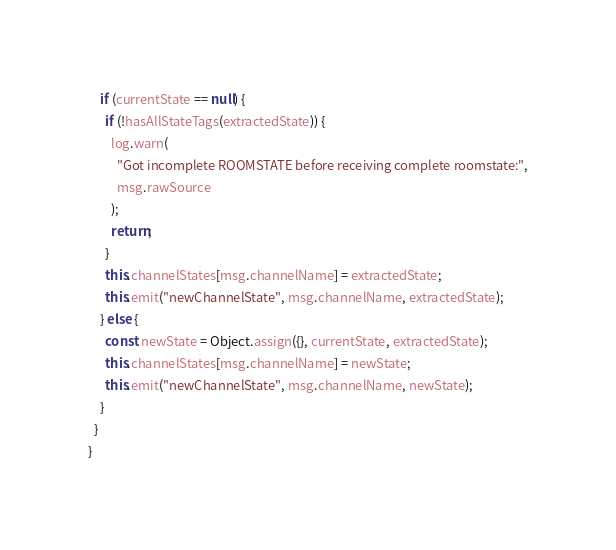Convert code to text. <code><loc_0><loc_0><loc_500><loc_500><_TypeScript_>    if (currentState == null) {
      if (!hasAllStateTags(extractedState)) {
        log.warn(
          "Got incomplete ROOMSTATE before receiving complete roomstate:",
          msg.rawSource
        );
        return;
      }
      this.channelStates[msg.channelName] = extractedState;
      this.emit("newChannelState", msg.channelName, extractedState);
    } else {
      const newState = Object.assign({}, currentState, extractedState);
      this.channelStates[msg.channelName] = newState;
      this.emit("newChannelState", msg.channelName, newState);
    }
  }
}
</code> 